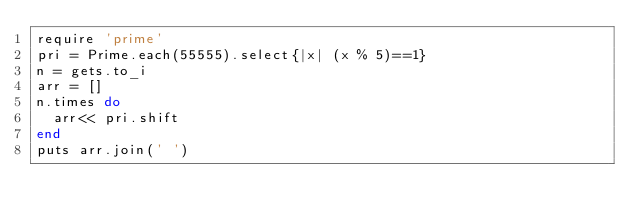Convert code to text. <code><loc_0><loc_0><loc_500><loc_500><_Ruby_>require 'prime'
pri = Prime.each(55555).select{|x| (x % 5)==1}
n = gets.to_i
arr = []
n.times do
  arr<< pri.shift
end
puts arr.join(' ')</code> 